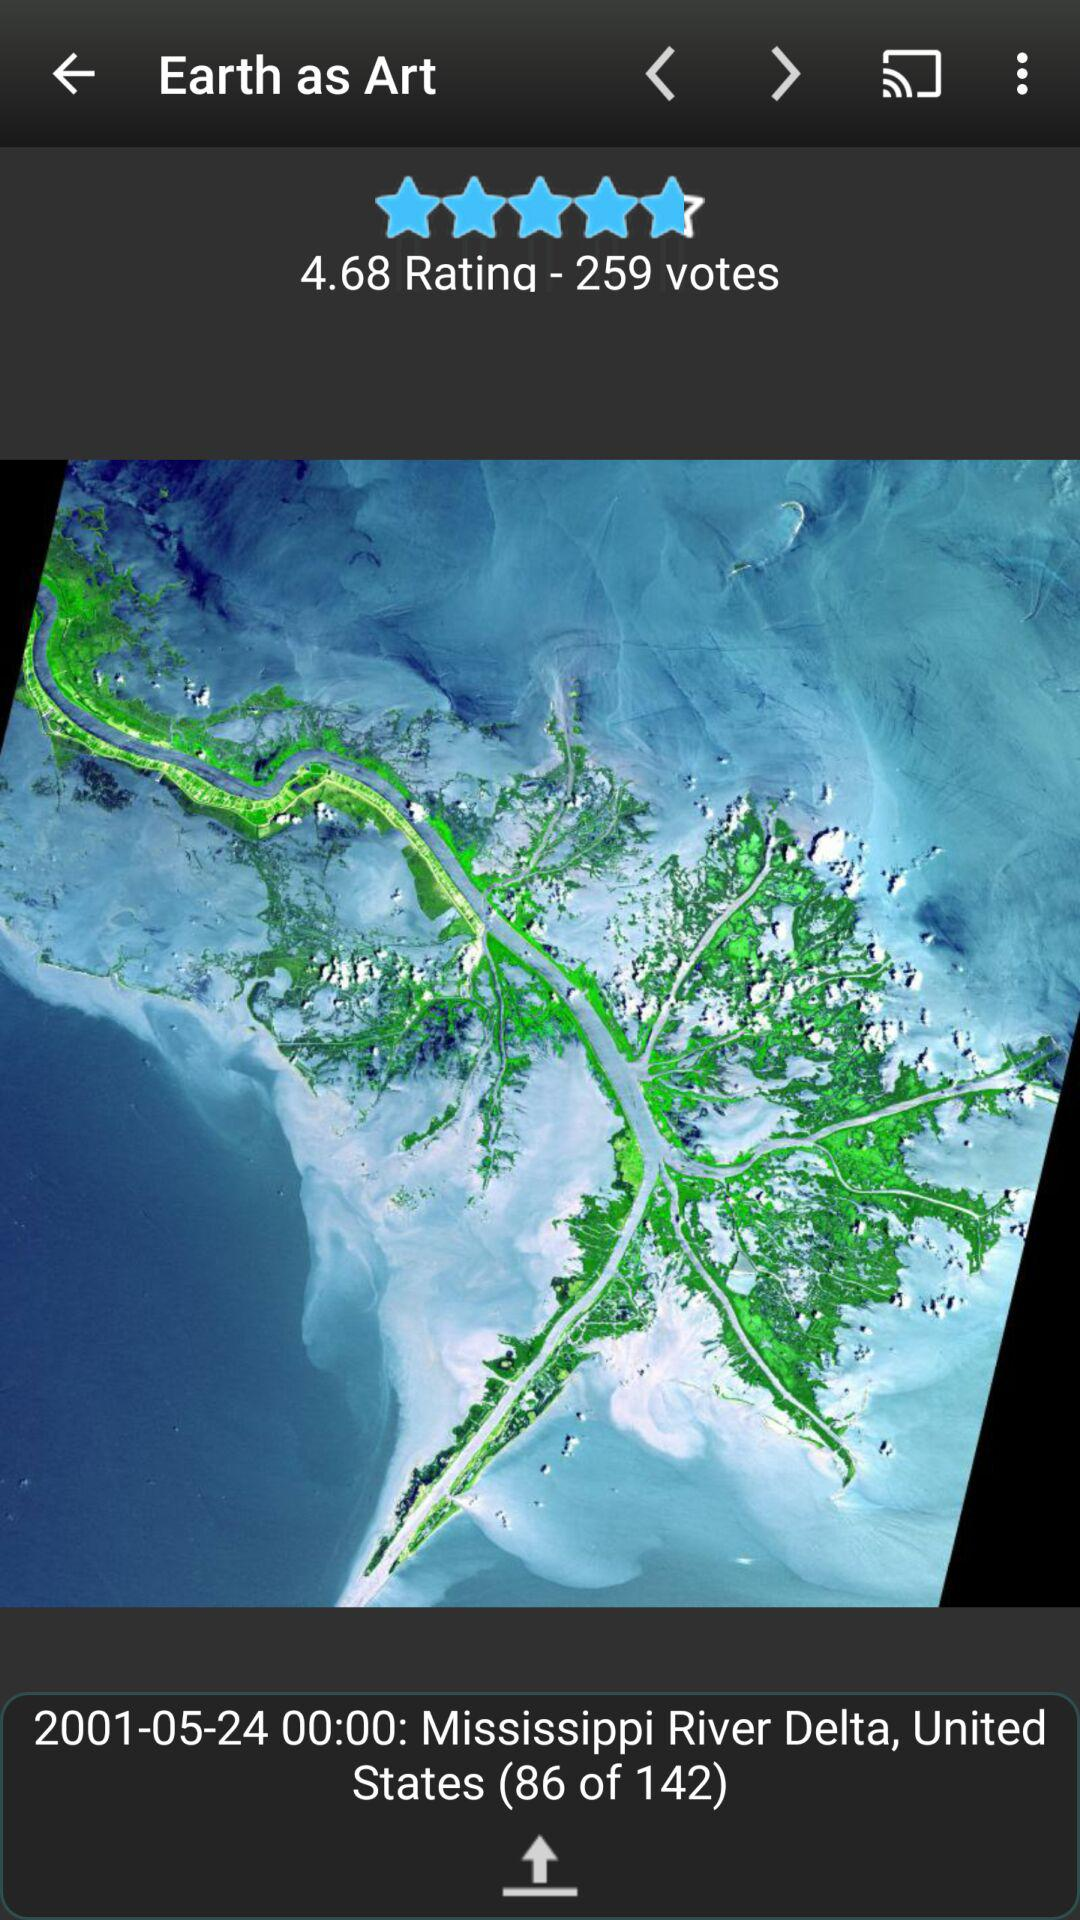What is the river's name? The river's name is the Mississippi River Delta. 